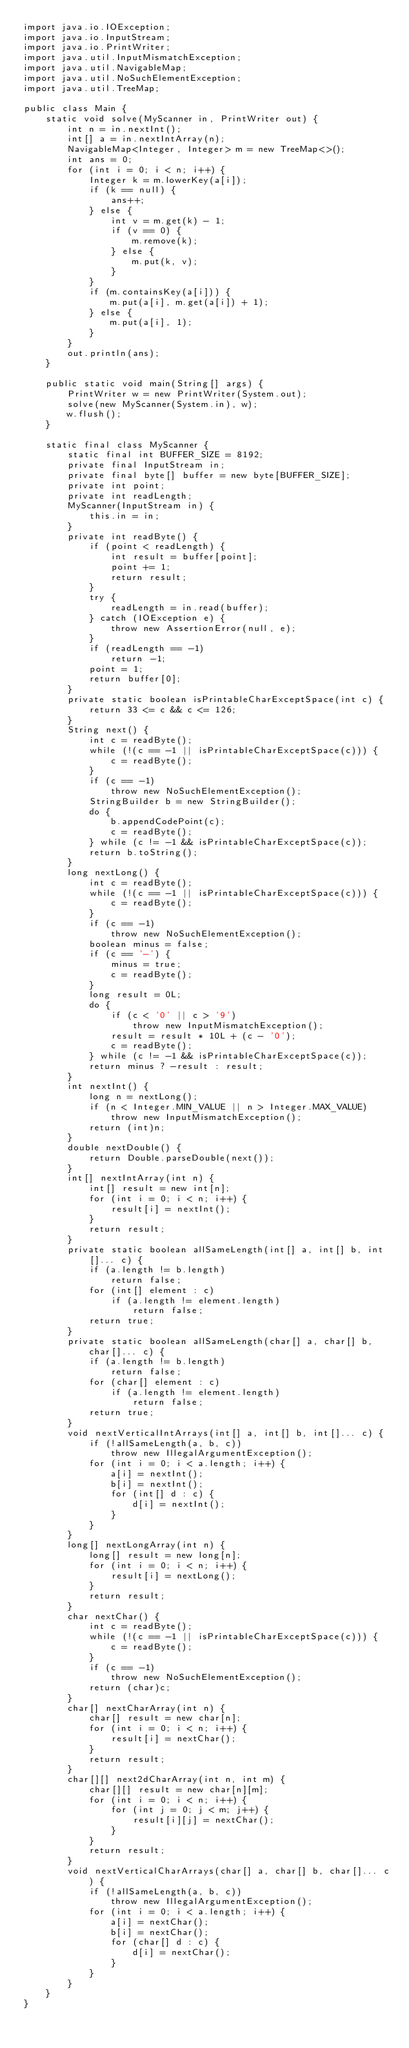Convert code to text. <code><loc_0><loc_0><loc_500><loc_500><_Java_>import java.io.IOException;
import java.io.InputStream;
import java.io.PrintWriter;
import java.util.InputMismatchException;
import java.util.NavigableMap;
import java.util.NoSuchElementException;
import java.util.TreeMap;

public class Main {
    static void solve(MyScanner in, PrintWriter out) {
        int n = in.nextInt();
        int[] a = in.nextIntArray(n);
        NavigableMap<Integer, Integer> m = new TreeMap<>();
        int ans = 0;
        for (int i = 0; i < n; i++) {
            Integer k = m.lowerKey(a[i]);
            if (k == null) {
                ans++;
            } else {
                int v = m.get(k) - 1;
                if (v == 0) {
                    m.remove(k);
                } else {
                    m.put(k, v);
                }
            }
            if (m.containsKey(a[i])) {
                m.put(a[i], m.get(a[i]) + 1);
            } else {
                m.put(a[i], 1);
            }
        }
        out.println(ans);
    }

    public static void main(String[] args) {
        PrintWriter w = new PrintWriter(System.out);
        solve(new MyScanner(System.in), w);
        w.flush();
    }

    static final class MyScanner {
        static final int BUFFER_SIZE = 8192;
        private final InputStream in;
        private final byte[] buffer = new byte[BUFFER_SIZE];
        private int point;
        private int readLength;
        MyScanner(InputStream in) {
            this.in = in;
        }
        private int readByte() {
            if (point < readLength) {
                int result = buffer[point];
                point += 1;
                return result;
            }
            try {
                readLength = in.read(buffer);
            } catch (IOException e) {
                throw new AssertionError(null, e);
            }
            if (readLength == -1)
                return -1;
            point = 1;
            return buffer[0];
        }
        private static boolean isPrintableCharExceptSpace(int c) {
            return 33 <= c && c <= 126;
        }
        String next() {
            int c = readByte();
            while (!(c == -1 || isPrintableCharExceptSpace(c))) {
                c = readByte();
            }
            if (c == -1)
                throw new NoSuchElementException();
            StringBuilder b = new StringBuilder();
            do {
                b.appendCodePoint(c);
                c = readByte();
            } while (c != -1 && isPrintableCharExceptSpace(c));
            return b.toString();
        }
        long nextLong() {
            int c = readByte();
            while (!(c == -1 || isPrintableCharExceptSpace(c))) {
                c = readByte();
            }
            if (c == -1)
                throw new NoSuchElementException();
            boolean minus = false;
            if (c == '-') {
                minus = true;
                c = readByte();
            }
            long result = 0L;
            do {
                if (c < '0' || c > '9')
                    throw new InputMismatchException();
                result = result * 10L + (c - '0');
                c = readByte();
            } while (c != -1 && isPrintableCharExceptSpace(c));
            return minus ? -result : result;
        }
        int nextInt() {
            long n = nextLong();
            if (n < Integer.MIN_VALUE || n > Integer.MAX_VALUE)
                throw new InputMismatchException();
            return (int)n;
        }
        double nextDouble() {
            return Double.parseDouble(next());
        }
        int[] nextIntArray(int n) {
            int[] result = new int[n];
            for (int i = 0; i < n; i++) {
                result[i] = nextInt();
            }
            return result;
        }
        private static boolean allSameLength(int[] a, int[] b, int[]... c) {
            if (a.length != b.length)
                return false;
            for (int[] element : c)
                if (a.length != element.length)
                    return false;
            return true;
        }
        private static boolean allSameLength(char[] a, char[] b, char[]... c) {
            if (a.length != b.length)
                return false;
            for (char[] element : c)
                if (a.length != element.length)
                    return false;
            return true;
        }
        void nextVerticalIntArrays(int[] a, int[] b, int[]... c) {
            if (!allSameLength(a, b, c))
                throw new IllegalArgumentException();
            for (int i = 0; i < a.length; i++) {
                a[i] = nextInt();
                b[i] = nextInt();
                for (int[] d : c) {
                    d[i] = nextInt();
                }
            }
        }
        long[] nextLongArray(int n) {
            long[] result = new long[n];
            for (int i = 0; i < n; i++) {
                result[i] = nextLong();
            }
            return result;
        }
        char nextChar() {
            int c = readByte();
            while (!(c == -1 || isPrintableCharExceptSpace(c))) {
                c = readByte();
            }
            if (c == -1)
                throw new NoSuchElementException();
            return (char)c;
        }
        char[] nextCharArray(int n) {
            char[] result = new char[n];
            for (int i = 0; i < n; i++) {
                result[i] = nextChar();
            }
            return result;
        }
        char[][] next2dCharArray(int n, int m) {
            char[][] result = new char[n][m];
            for (int i = 0; i < n; i++) {
                for (int j = 0; j < m; j++) {
                    result[i][j] = nextChar();
                }
            }
            return result;
        }
        void nextVerticalCharArrays(char[] a, char[] b, char[]... c) {
            if (!allSameLength(a, b, c))
                throw new IllegalArgumentException();
            for (int i = 0; i < a.length; i++) {
                a[i] = nextChar();
                b[i] = nextChar();
                for (char[] d : c) {
                    d[i] = nextChar();
                }
            }
        }
    }
}
</code> 